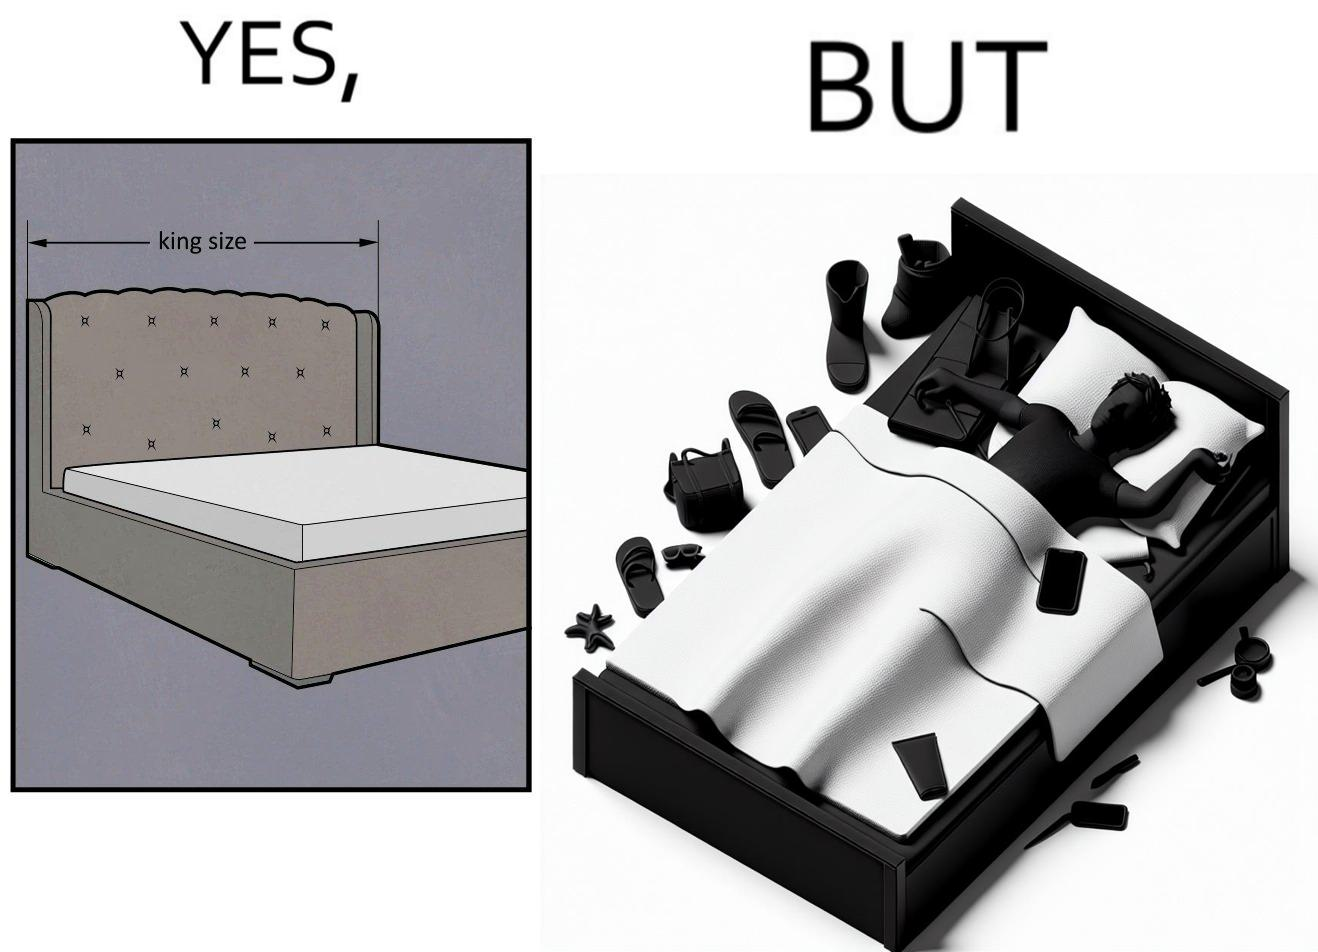Compare the left and right sides of this image. In the left part of the image: There is a bed of king size. In the right part of the image: There is a person sleeping with his material on its bed; 